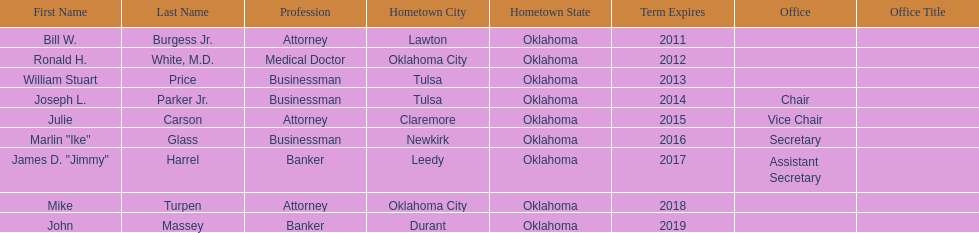Which state regent's term will last the longest? John Massey. 